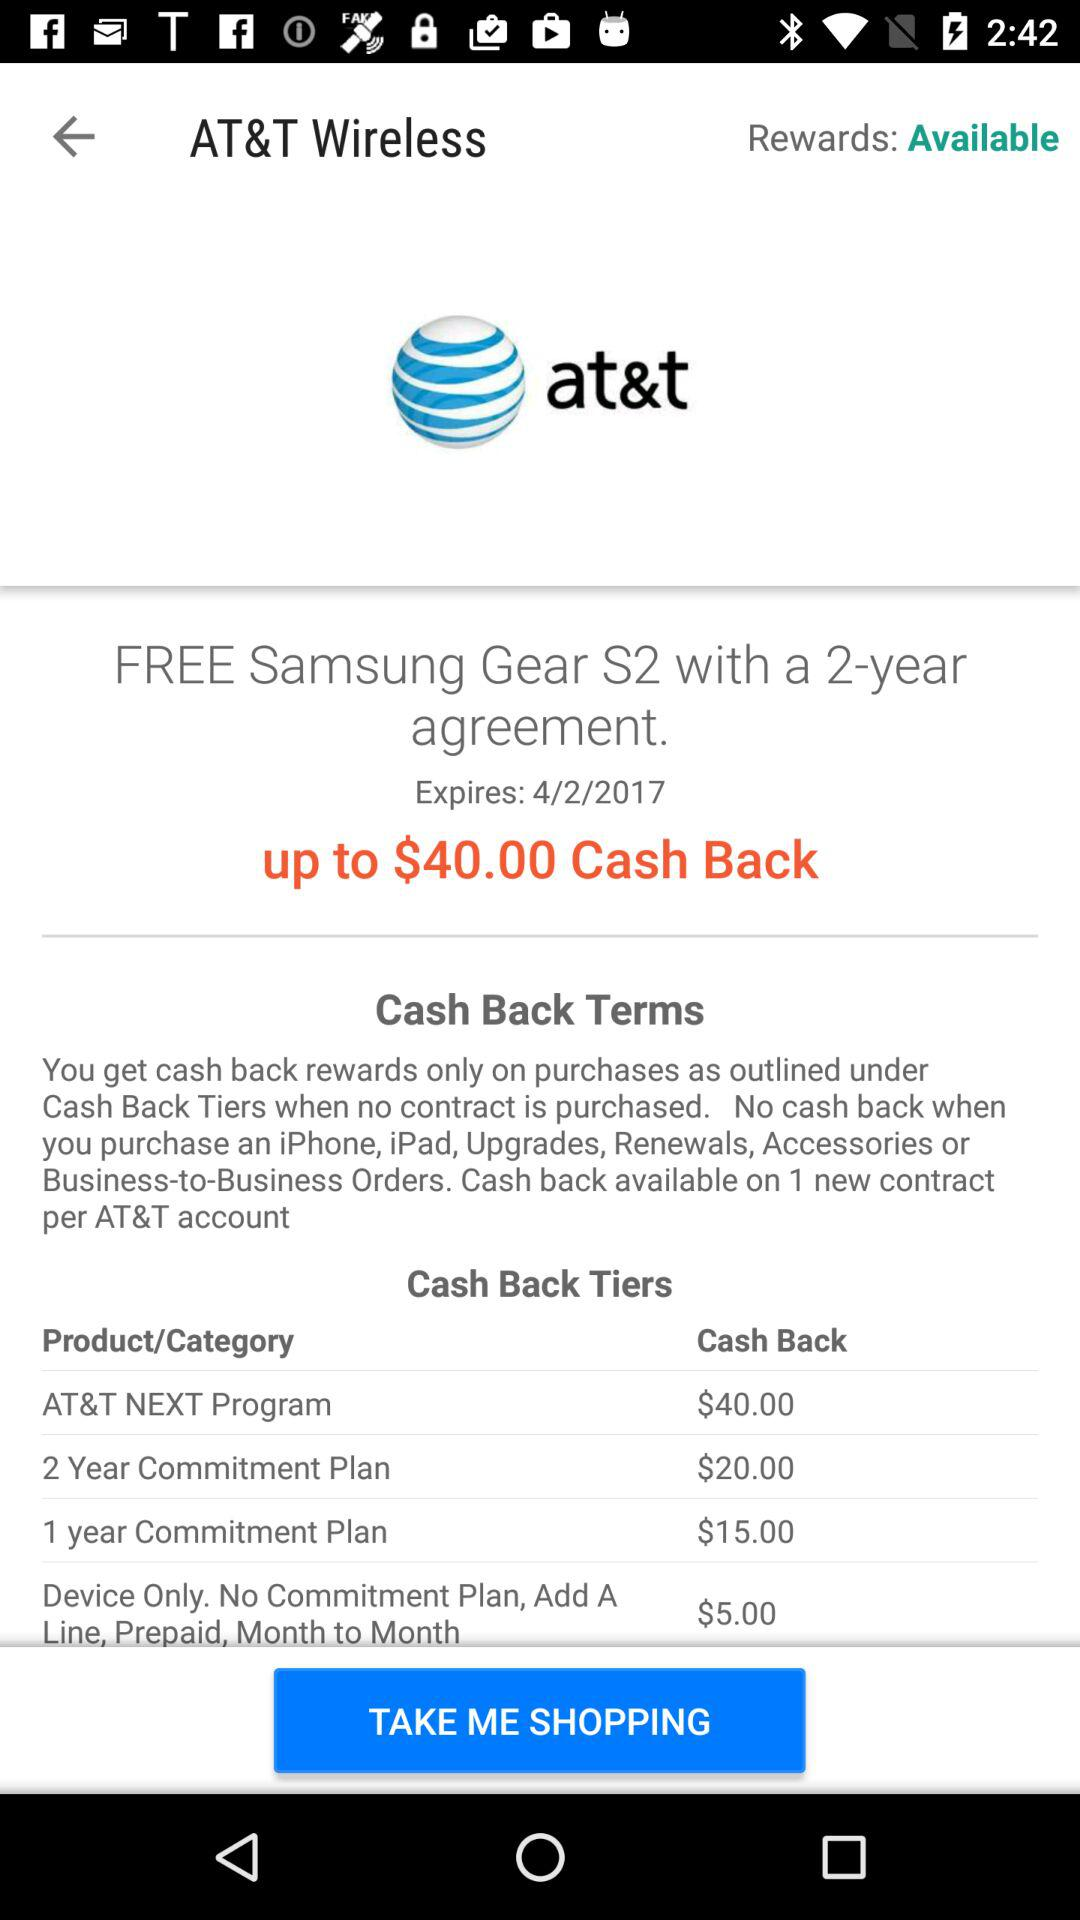How many dollars of cash back is offered for a device only purchase?
Answer the question using a single word or phrase. $5.00 